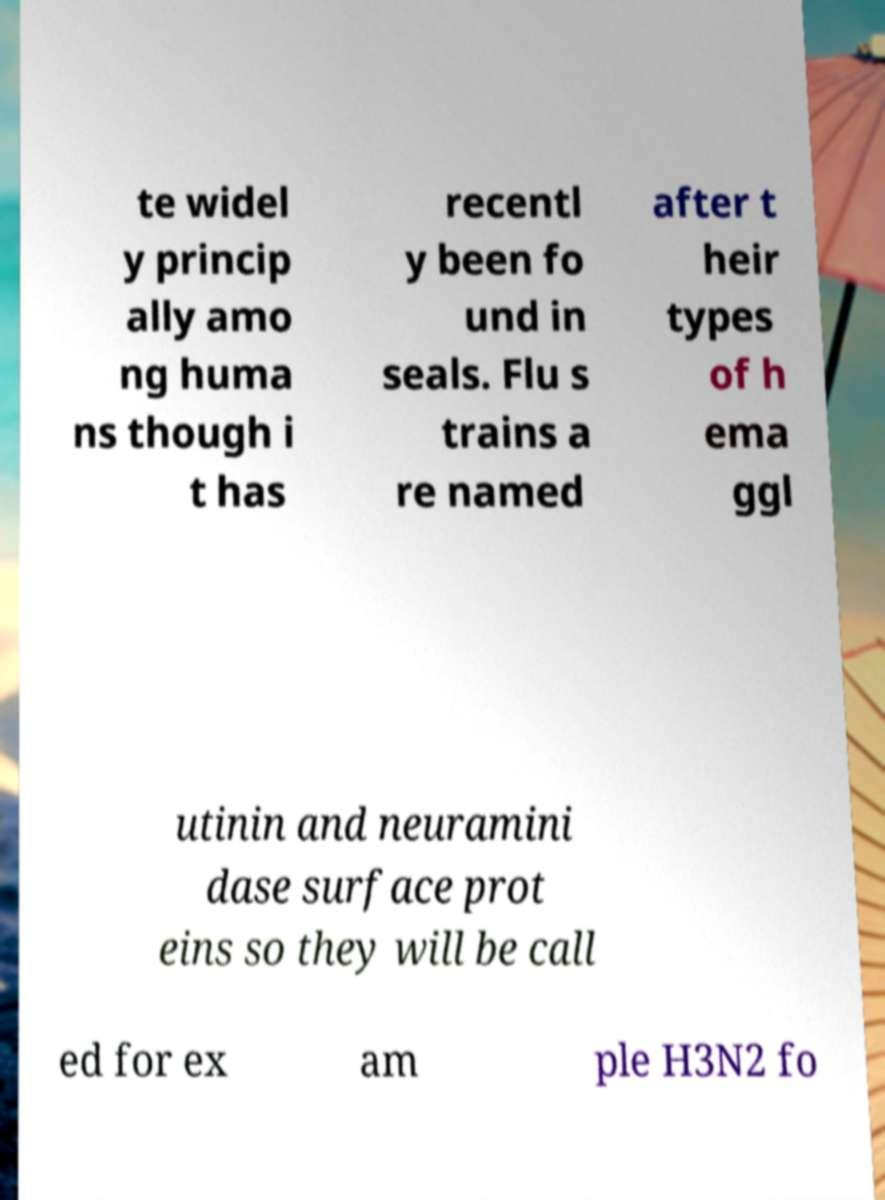Please read and relay the text visible in this image. What does it say? te widel y princip ally amo ng huma ns though i t has recentl y been fo und in seals. Flu s trains a re named after t heir types of h ema ggl utinin and neuramini dase surface prot eins so they will be call ed for ex am ple H3N2 fo 